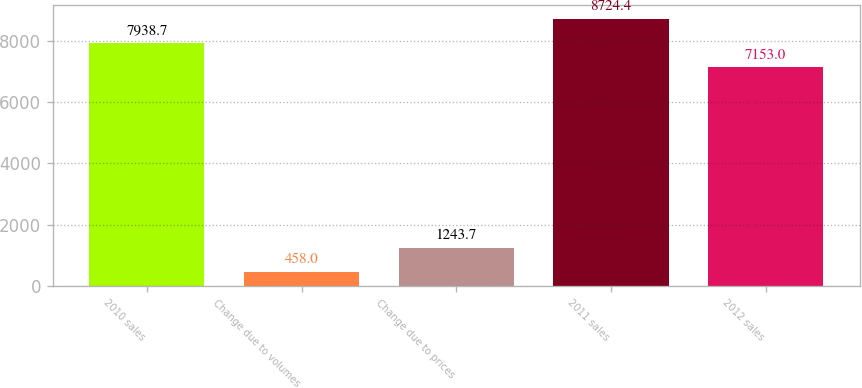<chart> <loc_0><loc_0><loc_500><loc_500><bar_chart><fcel>2010 sales<fcel>Change due to volumes<fcel>Change due to prices<fcel>2011 sales<fcel>2012 sales<nl><fcel>7938.7<fcel>458<fcel>1243.7<fcel>8724.4<fcel>7153<nl></chart> 